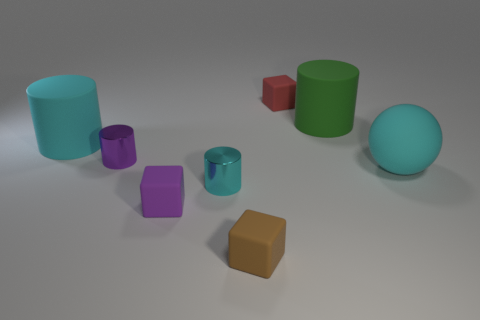Subtract all blue spheres. Subtract all yellow cylinders. How many spheres are left? 1 Subtract all cyan cubes. How many purple spheres are left? 0 Add 7 things. How many small reds exist? 0 Subtract all big matte things. Subtract all small red blocks. How many objects are left? 4 Add 3 tiny red rubber objects. How many tiny red rubber objects are left? 4 Add 1 cyan metallic cylinders. How many cyan metallic cylinders exist? 2 Add 1 brown rubber things. How many objects exist? 9 Subtract all purple cubes. How many cubes are left? 2 Subtract all large cyan matte cylinders. How many cylinders are left? 3 Subtract 0 blue spheres. How many objects are left? 8 